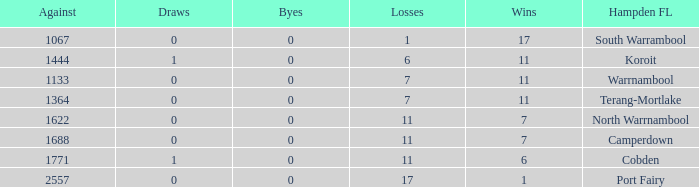Help me parse the entirety of this table. {'header': ['Against', 'Draws', 'Byes', 'Losses', 'Wins', 'Hampden FL'], 'rows': [['1067', '0', '0', '1', '17', 'South Warrambool'], ['1444', '1', '0', '6', '11', 'Koroit'], ['1133', '0', '0', '7', '11', 'Warrnambool'], ['1364', '0', '0', '7', '11', 'Terang-Mortlake'], ['1622', '0', '0', '11', '7', 'North Warrnambool'], ['1688', '0', '0', '11', '7', 'Camperdown'], ['1771', '1', '0', '11', '6', 'Cobden'], ['2557', '0', '0', '17', '1', 'Port Fairy']]} What were the losses when the byes were less than 0? None. 